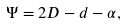Convert formula to latex. <formula><loc_0><loc_0><loc_500><loc_500>\Psi = 2 D - d - \alpha ,</formula> 